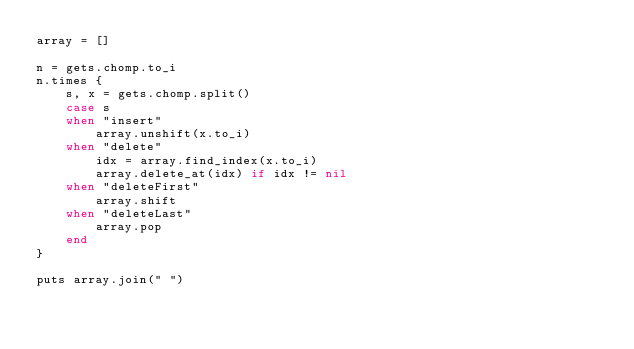<code> <loc_0><loc_0><loc_500><loc_500><_Ruby_>array = []

n = gets.chomp.to_i
n.times {
    s, x = gets.chomp.split()
    case s
    when "insert"
        array.unshift(x.to_i)
    when "delete"
        idx = array.find_index(x.to_i)
        array.delete_at(idx) if idx != nil
    when "deleteFirst"
        array.shift
    when "deleteLast"
        array.pop
    end
}

puts array.join(" ")
</code> 